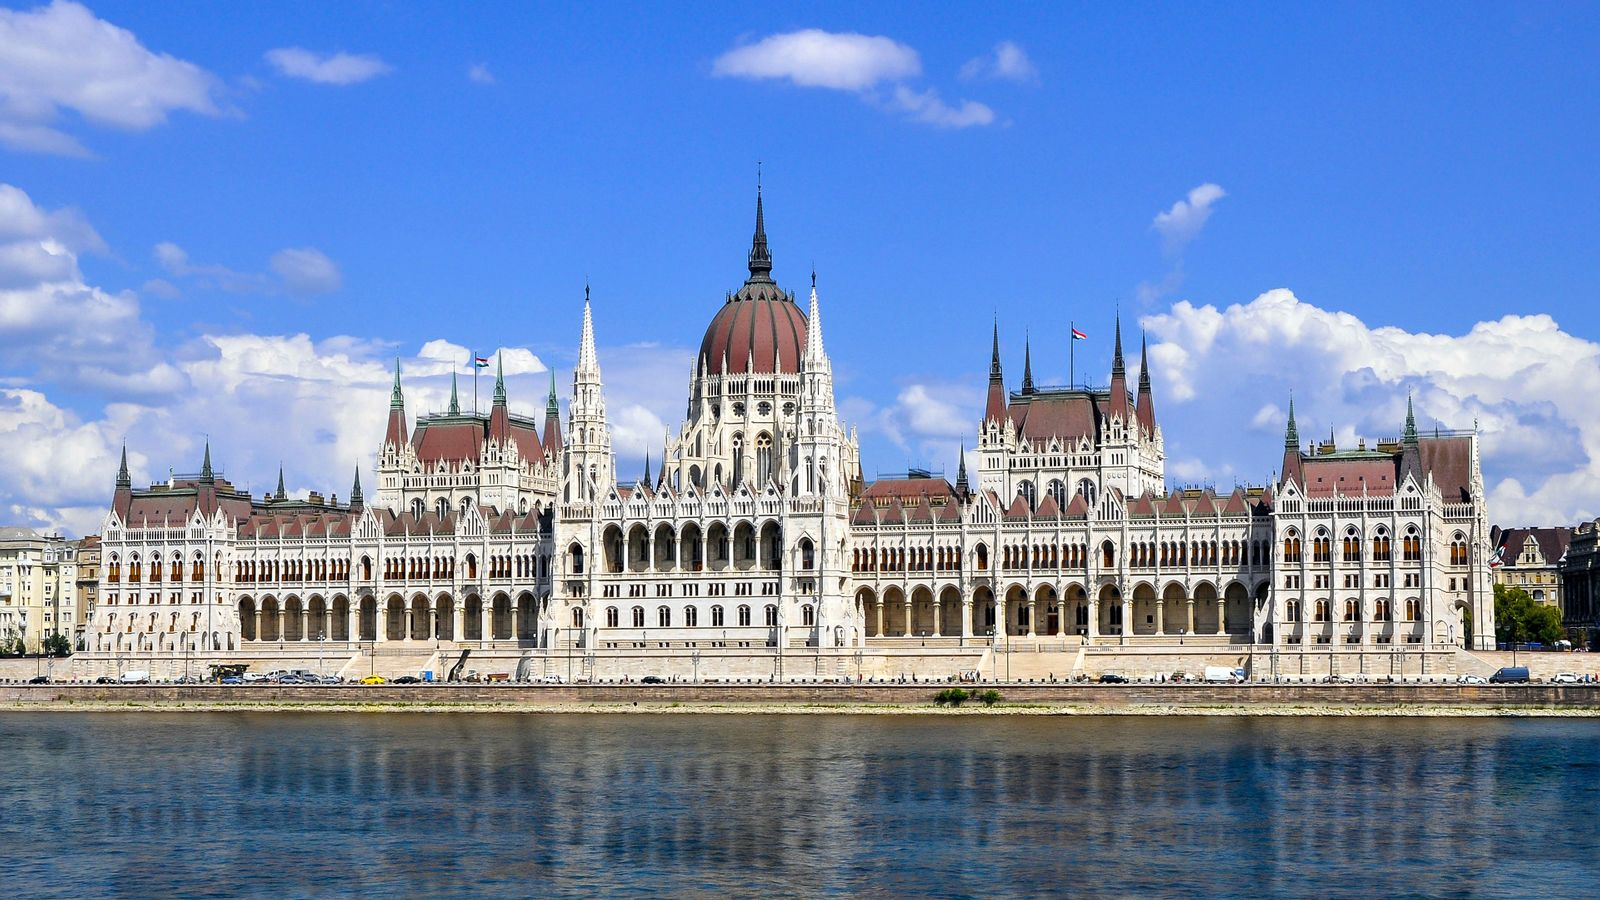Explain the visual content of the image in great detail. The image displays the Hungarian Parliament Building, an iconic masterpiece located in Budapest, Hungary. This stunning architectural phenomenon sits prominently along the banks of the serene Danube River. The Parliament Building features an imposing and grand design characterized by a significant central dome surrounded by a multitude of spires reaching towards the sky. The intricacies of the facade are captivating, with the predominance of white stone accented by red tiles, creating a mesmerizing contrast. Detailed patterns and elaborate craftsmanship highlight the neogothic style of architecture, demonstrating the meticulous effort involved in its construction. The photograph, taken at an ample distance, offers a comprehensive view, allowing one to appreciate the scale and complexity of the entire structure, including the adjacent buildings. The backdrop of a clear, vibrant blue sky enhances the overall visual appeal, while fluffy clouds add a picturesque element, making the scene even more enchanting and tranquil, capturing the essence of Budapest’s timeless beauty. 